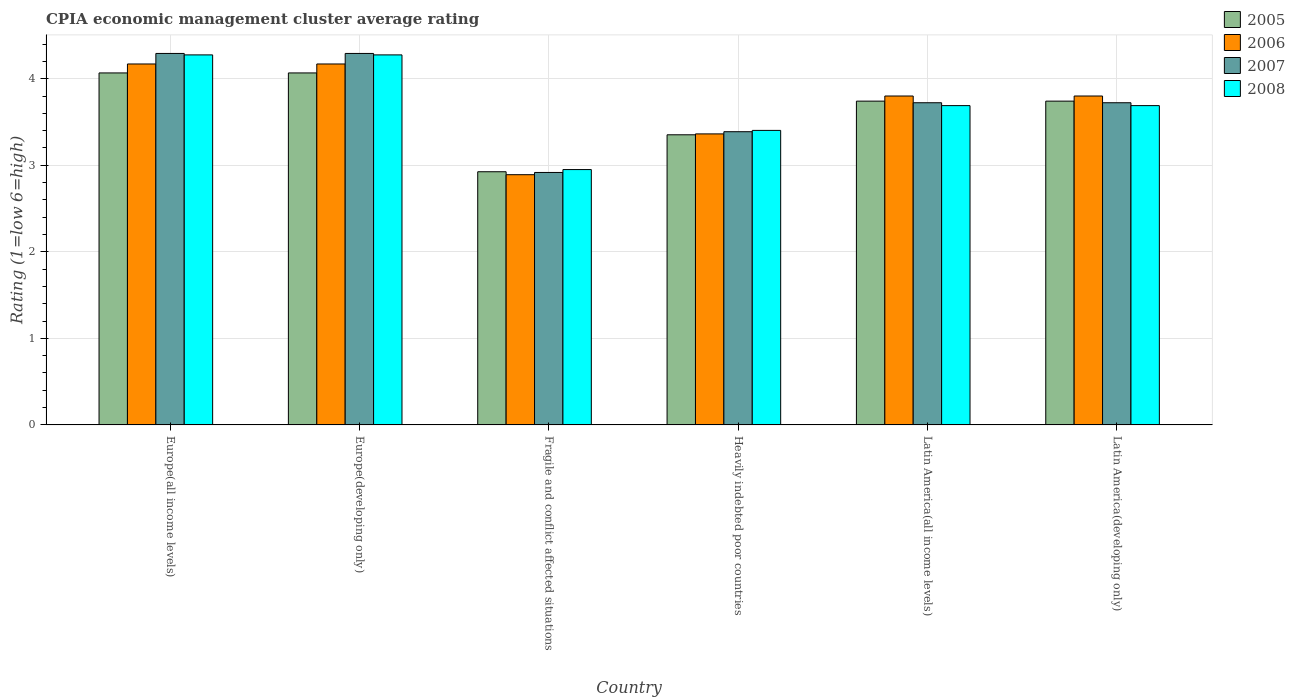Are the number of bars per tick equal to the number of legend labels?
Your answer should be very brief. Yes. Are the number of bars on each tick of the X-axis equal?
Your answer should be compact. Yes. How many bars are there on the 2nd tick from the right?
Make the answer very short. 4. What is the label of the 5th group of bars from the left?
Your answer should be compact. Latin America(all income levels). In how many cases, is the number of bars for a given country not equal to the number of legend labels?
Ensure brevity in your answer.  0. What is the CPIA rating in 2006 in Fragile and conflict affected situations?
Your answer should be very brief. 2.89. Across all countries, what is the maximum CPIA rating in 2006?
Provide a succinct answer. 4.17. Across all countries, what is the minimum CPIA rating in 2006?
Provide a succinct answer. 2.89. In which country was the CPIA rating in 2007 maximum?
Ensure brevity in your answer.  Europe(all income levels). In which country was the CPIA rating in 2006 minimum?
Provide a short and direct response. Fragile and conflict affected situations. What is the total CPIA rating in 2005 in the graph?
Ensure brevity in your answer.  21.89. What is the difference between the CPIA rating in 2006 in Europe(developing only) and that in Fragile and conflict affected situations?
Provide a succinct answer. 1.28. What is the difference between the CPIA rating in 2008 in Fragile and conflict affected situations and the CPIA rating in 2005 in Heavily indebted poor countries?
Make the answer very short. -0.4. What is the average CPIA rating in 2005 per country?
Provide a short and direct response. 3.65. What is the difference between the CPIA rating of/in 2006 and CPIA rating of/in 2008 in Fragile and conflict affected situations?
Make the answer very short. -0.06. What is the ratio of the CPIA rating in 2006 in Europe(developing only) to that in Latin America(all income levels)?
Your answer should be compact. 1.1. Is the difference between the CPIA rating in 2006 in Europe(developing only) and Latin America(all income levels) greater than the difference between the CPIA rating in 2008 in Europe(developing only) and Latin America(all income levels)?
Offer a terse response. No. What is the difference between the highest and the second highest CPIA rating in 2007?
Your response must be concise. -0.57. What is the difference between the highest and the lowest CPIA rating in 2006?
Your response must be concise. 1.28. Is it the case that in every country, the sum of the CPIA rating in 2007 and CPIA rating in 2005 is greater than the sum of CPIA rating in 2008 and CPIA rating in 2006?
Offer a terse response. No. Is it the case that in every country, the sum of the CPIA rating in 2005 and CPIA rating in 2006 is greater than the CPIA rating in 2008?
Your answer should be compact. Yes. How many bars are there?
Ensure brevity in your answer.  24. Are the values on the major ticks of Y-axis written in scientific E-notation?
Keep it short and to the point. No. Where does the legend appear in the graph?
Provide a succinct answer. Top right. How are the legend labels stacked?
Give a very brief answer. Vertical. What is the title of the graph?
Your answer should be compact. CPIA economic management cluster average rating. Does "1971" appear as one of the legend labels in the graph?
Keep it short and to the point. No. What is the label or title of the Y-axis?
Your answer should be compact. Rating (1=low 6=high). What is the Rating (1=low 6=high) in 2005 in Europe(all income levels)?
Give a very brief answer. 4.07. What is the Rating (1=low 6=high) of 2006 in Europe(all income levels)?
Make the answer very short. 4.17. What is the Rating (1=low 6=high) of 2007 in Europe(all income levels)?
Keep it short and to the point. 4.29. What is the Rating (1=low 6=high) of 2008 in Europe(all income levels)?
Your response must be concise. 4.28. What is the Rating (1=low 6=high) of 2005 in Europe(developing only)?
Provide a succinct answer. 4.07. What is the Rating (1=low 6=high) of 2006 in Europe(developing only)?
Provide a succinct answer. 4.17. What is the Rating (1=low 6=high) of 2007 in Europe(developing only)?
Provide a succinct answer. 4.29. What is the Rating (1=low 6=high) of 2008 in Europe(developing only)?
Provide a succinct answer. 4.28. What is the Rating (1=low 6=high) of 2005 in Fragile and conflict affected situations?
Your answer should be very brief. 2.92. What is the Rating (1=low 6=high) of 2006 in Fragile and conflict affected situations?
Ensure brevity in your answer.  2.89. What is the Rating (1=low 6=high) of 2007 in Fragile and conflict affected situations?
Keep it short and to the point. 2.92. What is the Rating (1=low 6=high) in 2008 in Fragile and conflict affected situations?
Offer a very short reply. 2.95. What is the Rating (1=low 6=high) in 2005 in Heavily indebted poor countries?
Offer a very short reply. 3.35. What is the Rating (1=low 6=high) of 2006 in Heavily indebted poor countries?
Your response must be concise. 3.36. What is the Rating (1=low 6=high) in 2007 in Heavily indebted poor countries?
Offer a very short reply. 3.39. What is the Rating (1=low 6=high) of 2008 in Heavily indebted poor countries?
Give a very brief answer. 3.4. What is the Rating (1=low 6=high) in 2005 in Latin America(all income levels)?
Provide a succinct answer. 3.74. What is the Rating (1=low 6=high) in 2007 in Latin America(all income levels)?
Offer a very short reply. 3.72. What is the Rating (1=low 6=high) of 2008 in Latin America(all income levels)?
Your answer should be very brief. 3.69. What is the Rating (1=low 6=high) of 2005 in Latin America(developing only)?
Ensure brevity in your answer.  3.74. What is the Rating (1=low 6=high) in 2006 in Latin America(developing only)?
Give a very brief answer. 3.8. What is the Rating (1=low 6=high) of 2007 in Latin America(developing only)?
Provide a short and direct response. 3.72. What is the Rating (1=low 6=high) in 2008 in Latin America(developing only)?
Your answer should be compact. 3.69. Across all countries, what is the maximum Rating (1=low 6=high) of 2005?
Your response must be concise. 4.07. Across all countries, what is the maximum Rating (1=low 6=high) in 2006?
Offer a terse response. 4.17. Across all countries, what is the maximum Rating (1=low 6=high) in 2007?
Make the answer very short. 4.29. Across all countries, what is the maximum Rating (1=low 6=high) in 2008?
Offer a very short reply. 4.28. Across all countries, what is the minimum Rating (1=low 6=high) of 2005?
Offer a very short reply. 2.92. Across all countries, what is the minimum Rating (1=low 6=high) in 2006?
Offer a terse response. 2.89. Across all countries, what is the minimum Rating (1=low 6=high) in 2007?
Your answer should be very brief. 2.92. Across all countries, what is the minimum Rating (1=low 6=high) in 2008?
Provide a succinct answer. 2.95. What is the total Rating (1=low 6=high) of 2005 in the graph?
Your answer should be compact. 21.89. What is the total Rating (1=low 6=high) of 2006 in the graph?
Your answer should be very brief. 22.19. What is the total Rating (1=low 6=high) of 2007 in the graph?
Your answer should be very brief. 22.33. What is the total Rating (1=low 6=high) in 2008 in the graph?
Give a very brief answer. 22.28. What is the difference between the Rating (1=low 6=high) of 2006 in Europe(all income levels) and that in Europe(developing only)?
Keep it short and to the point. 0. What is the difference between the Rating (1=low 6=high) in 2005 in Europe(all income levels) and that in Fragile and conflict affected situations?
Ensure brevity in your answer.  1.14. What is the difference between the Rating (1=low 6=high) of 2006 in Europe(all income levels) and that in Fragile and conflict affected situations?
Your response must be concise. 1.28. What is the difference between the Rating (1=low 6=high) in 2007 in Europe(all income levels) and that in Fragile and conflict affected situations?
Provide a short and direct response. 1.38. What is the difference between the Rating (1=low 6=high) of 2008 in Europe(all income levels) and that in Fragile and conflict affected situations?
Keep it short and to the point. 1.32. What is the difference between the Rating (1=low 6=high) of 2005 in Europe(all income levels) and that in Heavily indebted poor countries?
Your answer should be compact. 0.71. What is the difference between the Rating (1=low 6=high) of 2006 in Europe(all income levels) and that in Heavily indebted poor countries?
Make the answer very short. 0.81. What is the difference between the Rating (1=low 6=high) of 2007 in Europe(all income levels) and that in Heavily indebted poor countries?
Offer a terse response. 0.9. What is the difference between the Rating (1=low 6=high) in 2008 in Europe(all income levels) and that in Heavily indebted poor countries?
Ensure brevity in your answer.  0.87. What is the difference between the Rating (1=low 6=high) of 2005 in Europe(all income levels) and that in Latin America(all income levels)?
Give a very brief answer. 0.33. What is the difference between the Rating (1=low 6=high) in 2006 in Europe(all income levels) and that in Latin America(all income levels)?
Your response must be concise. 0.37. What is the difference between the Rating (1=low 6=high) in 2007 in Europe(all income levels) and that in Latin America(all income levels)?
Provide a succinct answer. 0.57. What is the difference between the Rating (1=low 6=high) in 2008 in Europe(all income levels) and that in Latin America(all income levels)?
Your answer should be very brief. 0.59. What is the difference between the Rating (1=low 6=high) of 2005 in Europe(all income levels) and that in Latin America(developing only)?
Keep it short and to the point. 0.33. What is the difference between the Rating (1=low 6=high) of 2006 in Europe(all income levels) and that in Latin America(developing only)?
Give a very brief answer. 0.37. What is the difference between the Rating (1=low 6=high) in 2007 in Europe(all income levels) and that in Latin America(developing only)?
Provide a short and direct response. 0.57. What is the difference between the Rating (1=low 6=high) of 2008 in Europe(all income levels) and that in Latin America(developing only)?
Ensure brevity in your answer.  0.59. What is the difference between the Rating (1=low 6=high) of 2005 in Europe(developing only) and that in Fragile and conflict affected situations?
Provide a succinct answer. 1.14. What is the difference between the Rating (1=low 6=high) of 2006 in Europe(developing only) and that in Fragile and conflict affected situations?
Ensure brevity in your answer.  1.28. What is the difference between the Rating (1=low 6=high) in 2007 in Europe(developing only) and that in Fragile and conflict affected situations?
Give a very brief answer. 1.38. What is the difference between the Rating (1=low 6=high) of 2008 in Europe(developing only) and that in Fragile and conflict affected situations?
Keep it short and to the point. 1.32. What is the difference between the Rating (1=low 6=high) in 2005 in Europe(developing only) and that in Heavily indebted poor countries?
Make the answer very short. 0.71. What is the difference between the Rating (1=low 6=high) of 2006 in Europe(developing only) and that in Heavily indebted poor countries?
Provide a succinct answer. 0.81. What is the difference between the Rating (1=low 6=high) of 2007 in Europe(developing only) and that in Heavily indebted poor countries?
Make the answer very short. 0.9. What is the difference between the Rating (1=low 6=high) in 2008 in Europe(developing only) and that in Heavily indebted poor countries?
Provide a short and direct response. 0.87. What is the difference between the Rating (1=low 6=high) in 2005 in Europe(developing only) and that in Latin America(all income levels)?
Provide a succinct answer. 0.33. What is the difference between the Rating (1=low 6=high) of 2006 in Europe(developing only) and that in Latin America(all income levels)?
Offer a terse response. 0.37. What is the difference between the Rating (1=low 6=high) of 2007 in Europe(developing only) and that in Latin America(all income levels)?
Offer a terse response. 0.57. What is the difference between the Rating (1=low 6=high) of 2008 in Europe(developing only) and that in Latin America(all income levels)?
Provide a short and direct response. 0.59. What is the difference between the Rating (1=low 6=high) of 2005 in Europe(developing only) and that in Latin America(developing only)?
Offer a terse response. 0.33. What is the difference between the Rating (1=low 6=high) in 2006 in Europe(developing only) and that in Latin America(developing only)?
Your answer should be very brief. 0.37. What is the difference between the Rating (1=low 6=high) of 2007 in Europe(developing only) and that in Latin America(developing only)?
Offer a terse response. 0.57. What is the difference between the Rating (1=low 6=high) in 2008 in Europe(developing only) and that in Latin America(developing only)?
Make the answer very short. 0.59. What is the difference between the Rating (1=low 6=high) in 2005 in Fragile and conflict affected situations and that in Heavily indebted poor countries?
Offer a very short reply. -0.43. What is the difference between the Rating (1=low 6=high) of 2006 in Fragile and conflict affected situations and that in Heavily indebted poor countries?
Make the answer very short. -0.47. What is the difference between the Rating (1=low 6=high) of 2007 in Fragile and conflict affected situations and that in Heavily indebted poor countries?
Ensure brevity in your answer.  -0.47. What is the difference between the Rating (1=low 6=high) in 2008 in Fragile and conflict affected situations and that in Heavily indebted poor countries?
Keep it short and to the point. -0.45. What is the difference between the Rating (1=low 6=high) in 2005 in Fragile and conflict affected situations and that in Latin America(all income levels)?
Your answer should be compact. -0.82. What is the difference between the Rating (1=low 6=high) in 2006 in Fragile and conflict affected situations and that in Latin America(all income levels)?
Your response must be concise. -0.91. What is the difference between the Rating (1=low 6=high) in 2007 in Fragile and conflict affected situations and that in Latin America(all income levels)?
Ensure brevity in your answer.  -0.81. What is the difference between the Rating (1=low 6=high) in 2008 in Fragile and conflict affected situations and that in Latin America(all income levels)?
Make the answer very short. -0.74. What is the difference between the Rating (1=low 6=high) of 2005 in Fragile and conflict affected situations and that in Latin America(developing only)?
Offer a very short reply. -0.82. What is the difference between the Rating (1=low 6=high) of 2006 in Fragile and conflict affected situations and that in Latin America(developing only)?
Offer a very short reply. -0.91. What is the difference between the Rating (1=low 6=high) in 2007 in Fragile and conflict affected situations and that in Latin America(developing only)?
Offer a terse response. -0.81. What is the difference between the Rating (1=low 6=high) of 2008 in Fragile and conflict affected situations and that in Latin America(developing only)?
Ensure brevity in your answer.  -0.74. What is the difference between the Rating (1=low 6=high) of 2005 in Heavily indebted poor countries and that in Latin America(all income levels)?
Offer a terse response. -0.39. What is the difference between the Rating (1=low 6=high) of 2006 in Heavily indebted poor countries and that in Latin America(all income levels)?
Offer a very short reply. -0.44. What is the difference between the Rating (1=low 6=high) in 2007 in Heavily indebted poor countries and that in Latin America(all income levels)?
Your answer should be very brief. -0.33. What is the difference between the Rating (1=low 6=high) in 2008 in Heavily indebted poor countries and that in Latin America(all income levels)?
Give a very brief answer. -0.29. What is the difference between the Rating (1=low 6=high) in 2005 in Heavily indebted poor countries and that in Latin America(developing only)?
Offer a very short reply. -0.39. What is the difference between the Rating (1=low 6=high) of 2006 in Heavily indebted poor countries and that in Latin America(developing only)?
Make the answer very short. -0.44. What is the difference between the Rating (1=low 6=high) of 2007 in Heavily indebted poor countries and that in Latin America(developing only)?
Offer a very short reply. -0.33. What is the difference between the Rating (1=low 6=high) in 2008 in Heavily indebted poor countries and that in Latin America(developing only)?
Provide a succinct answer. -0.29. What is the difference between the Rating (1=low 6=high) of 2005 in Latin America(all income levels) and that in Latin America(developing only)?
Ensure brevity in your answer.  0. What is the difference between the Rating (1=low 6=high) of 2007 in Latin America(all income levels) and that in Latin America(developing only)?
Provide a succinct answer. 0. What is the difference between the Rating (1=low 6=high) in 2005 in Europe(all income levels) and the Rating (1=low 6=high) in 2006 in Europe(developing only)?
Give a very brief answer. -0.1. What is the difference between the Rating (1=low 6=high) in 2005 in Europe(all income levels) and the Rating (1=low 6=high) in 2007 in Europe(developing only)?
Ensure brevity in your answer.  -0.23. What is the difference between the Rating (1=low 6=high) of 2005 in Europe(all income levels) and the Rating (1=low 6=high) of 2008 in Europe(developing only)?
Offer a terse response. -0.21. What is the difference between the Rating (1=low 6=high) of 2006 in Europe(all income levels) and the Rating (1=low 6=high) of 2007 in Europe(developing only)?
Keep it short and to the point. -0.12. What is the difference between the Rating (1=low 6=high) in 2006 in Europe(all income levels) and the Rating (1=low 6=high) in 2008 in Europe(developing only)?
Offer a very short reply. -0.1. What is the difference between the Rating (1=low 6=high) of 2007 in Europe(all income levels) and the Rating (1=low 6=high) of 2008 in Europe(developing only)?
Your response must be concise. 0.02. What is the difference between the Rating (1=low 6=high) in 2005 in Europe(all income levels) and the Rating (1=low 6=high) in 2006 in Fragile and conflict affected situations?
Your answer should be compact. 1.18. What is the difference between the Rating (1=low 6=high) in 2005 in Europe(all income levels) and the Rating (1=low 6=high) in 2007 in Fragile and conflict affected situations?
Keep it short and to the point. 1.15. What is the difference between the Rating (1=low 6=high) in 2005 in Europe(all income levels) and the Rating (1=low 6=high) in 2008 in Fragile and conflict affected situations?
Ensure brevity in your answer.  1.12. What is the difference between the Rating (1=low 6=high) of 2006 in Europe(all income levels) and the Rating (1=low 6=high) of 2007 in Fragile and conflict affected situations?
Give a very brief answer. 1.25. What is the difference between the Rating (1=low 6=high) of 2006 in Europe(all income levels) and the Rating (1=low 6=high) of 2008 in Fragile and conflict affected situations?
Offer a terse response. 1.22. What is the difference between the Rating (1=low 6=high) in 2007 in Europe(all income levels) and the Rating (1=low 6=high) in 2008 in Fragile and conflict affected situations?
Your answer should be very brief. 1.34. What is the difference between the Rating (1=low 6=high) of 2005 in Europe(all income levels) and the Rating (1=low 6=high) of 2006 in Heavily indebted poor countries?
Your answer should be compact. 0.7. What is the difference between the Rating (1=low 6=high) of 2005 in Europe(all income levels) and the Rating (1=low 6=high) of 2007 in Heavily indebted poor countries?
Your answer should be very brief. 0.68. What is the difference between the Rating (1=low 6=high) of 2005 in Europe(all income levels) and the Rating (1=low 6=high) of 2008 in Heavily indebted poor countries?
Make the answer very short. 0.66. What is the difference between the Rating (1=low 6=high) of 2006 in Europe(all income levels) and the Rating (1=low 6=high) of 2007 in Heavily indebted poor countries?
Provide a short and direct response. 0.78. What is the difference between the Rating (1=low 6=high) of 2006 in Europe(all income levels) and the Rating (1=low 6=high) of 2008 in Heavily indebted poor countries?
Make the answer very short. 0.77. What is the difference between the Rating (1=low 6=high) in 2007 in Europe(all income levels) and the Rating (1=low 6=high) in 2008 in Heavily indebted poor countries?
Offer a very short reply. 0.89. What is the difference between the Rating (1=low 6=high) of 2005 in Europe(all income levels) and the Rating (1=low 6=high) of 2006 in Latin America(all income levels)?
Provide a short and direct response. 0.27. What is the difference between the Rating (1=low 6=high) of 2005 in Europe(all income levels) and the Rating (1=low 6=high) of 2007 in Latin America(all income levels)?
Make the answer very short. 0.34. What is the difference between the Rating (1=low 6=high) in 2005 in Europe(all income levels) and the Rating (1=low 6=high) in 2008 in Latin America(all income levels)?
Keep it short and to the point. 0.38. What is the difference between the Rating (1=low 6=high) of 2006 in Europe(all income levels) and the Rating (1=low 6=high) of 2007 in Latin America(all income levels)?
Your answer should be very brief. 0.45. What is the difference between the Rating (1=low 6=high) in 2006 in Europe(all income levels) and the Rating (1=low 6=high) in 2008 in Latin America(all income levels)?
Ensure brevity in your answer.  0.48. What is the difference between the Rating (1=low 6=high) in 2007 in Europe(all income levels) and the Rating (1=low 6=high) in 2008 in Latin America(all income levels)?
Ensure brevity in your answer.  0.6. What is the difference between the Rating (1=low 6=high) of 2005 in Europe(all income levels) and the Rating (1=low 6=high) of 2006 in Latin America(developing only)?
Your answer should be compact. 0.27. What is the difference between the Rating (1=low 6=high) of 2005 in Europe(all income levels) and the Rating (1=low 6=high) of 2007 in Latin America(developing only)?
Offer a terse response. 0.34. What is the difference between the Rating (1=low 6=high) of 2005 in Europe(all income levels) and the Rating (1=low 6=high) of 2008 in Latin America(developing only)?
Offer a very short reply. 0.38. What is the difference between the Rating (1=low 6=high) of 2006 in Europe(all income levels) and the Rating (1=low 6=high) of 2007 in Latin America(developing only)?
Offer a terse response. 0.45. What is the difference between the Rating (1=low 6=high) of 2006 in Europe(all income levels) and the Rating (1=low 6=high) of 2008 in Latin America(developing only)?
Offer a terse response. 0.48. What is the difference between the Rating (1=low 6=high) of 2007 in Europe(all income levels) and the Rating (1=low 6=high) of 2008 in Latin America(developing only)?
Your response must be concise. 0.6. What is the difference between the Rating (1=low 6=high) in 2005 in Europe(developing only) and the Rating (1=low 6=high) in 2006 in Fragile and conflict affected situations?
Keep it short and to the point. 1.18. What is the difference between the Rating (1=low 6=high) of 2005 in Europe(developing only) and the Rating (1=low 6=high) of 2007 in Fragile and conflict affected situations?
Provide a succinct answer. 1.15. What is the difference between the Rating (1=low 6=high) in 2005 in Europe(developing only) and the Rating (1=low 6=high) in 2008 in Fragile and conflict affected situations?
Your answer should be very brief. 1.12. What is the difference between the Rating (1=low 6=high) in 2006 in Europe(developing only) and the Rating (1=low 6=high) in 2007 in Fragile and conflict affected situations?
Your answer should be compact. 1.25. What is the difference between the Rating (1=low 6=high) of 2006 in Europe(developing only) and the Rating (1=low 6=high) of 2008 in Fragile and conflict affected situations?
Your answer should be very brief. 1.22. What is the difference between the Rating (1=low 6=high) in 2007 in Europe(developing only) and the Rating (1=low 6=high) in 2008 in Fragile and conflict affected situations?
Offer a terse response. 1.34. What is the difference between the Rating (1=low 6=high) of 2005 in Europe(developing only) and the Rating (1=low 6=high) of 2006 in Heavily indebted poor countries?
Your answer should be compact. 0.7. What is the difference between the Rating (1=low 6=high) in 2005 in Europe(developing only) and the Rating (1=low 6=high) in 2007 in Heavily indebted poor countries?
Your answer should be compact. 0.68. What is the difference between the Rating (1=low 6=high) in 2005 in Europe(developing only) and the Rating (1=low 6=high) in 2008 in Heavily indebted poor countries?
Your response must be concise. 0.66. What is the difference between the Rating (1=low 6=high) in 2006 in Europe(developing only) and the Rating (1=low 6=high) in 2007 in Heavily indebted poor countries?
Offer a terse response. 0.78. What is the difference between the Rating (1=low 6=high) in 2006 in Europe(developing only) and the Rating (1=low 6=high) in 2008 in Heavily indebted poor countries?
Give a very brief answer. 0.77. What is the difference between the Rating (1=low 6=high) in 2007 in Europe(developing only) and the Rating (1=low 6=high) in 2008 in Heavily indebted poor countries?
Your answer should be compact. 0.89. What is the difference between the Rating (1=low 6=high) in 2005 in Europe(developing only) and the Rating (1=low 6=high) in 2006 in Latin America(all income levels)?
Your response must be concise. 0.27. What is the difference between the Rating (1=low 6=high) in 2005 in Europe(developing only) and the Rating (1=low 6=high) in 2007 in Latin America(all income levels)?
Offer a very short reply. 0.34. What is the difference between the Rating (1=low 6=high) of 2005 in Europe(developing only) and the Rating (1=low 6=high) of 2008 in Latin America(all income levels)?
Provide a short and direct response. 0.38. What is the difference between the Rating (1=low 6=high) in 2006 in Europe(developing only) and the Rating (1=low 6=high) in 2007 in Latin America(all income levels)?
Your answer should be very brief. 0.45. What is the difference between the Rating (1=low 6=high) of 2006 in Europe(developing only) and the Rating (1=low 6=high) of 2008 in Latin America(all income levels)?
Offer a very short reply. 0.48. What is the difference between the Rating (1=low 6=high) of 2007 in Europe(developing only) and the Rating (1=low 6=high) of 2008 in Latin America(all income levels)?
Your answer should be compact. 0.6. What is the difference between the Rating (1=low 6=high) in 2005 in Europe(developing only) and the Rating (1=low 6=high) in 2006 in Latin America(developing only)?
Your answer should be compact. 0.27. What is the difference between the Rating (1=low 6=high) of 2005 in Europe(developing only) and the Rating (1=low 6=high) of 2007 in Latin America(developing only)?
Keep it short and to the point. 0.34. What is the difference between the Rating (1=low 6=high) of 2005 in Europe(developing only) and the Rating (1=low 6=high) of 2008 in Latin America(developing only)?
Give a very brief answer. 0.38. What is the difference between the Rating (1=low 6=high) in 2006 in Europe(developing only) and the Rating (1=low 6=high) in 2007 in Latin America(developing only)?
Keep it short and to the point. 0.45. What is the difference between the Rating (1=low 6=high) of 2006 in Europe(developing only) and the Rating (1=low 6=high) of 2008 in Latin America(developing only)?
Offer a very short reply. 0.48. What is the difference between the Rating (1=low 6=high) in 2007 in Europe(developing only) and the Rating (1=low 6=high) in 2008 in Latin America(developing only)?
Give a very brief answer. 0.6. What is the difference between the Rating (1=low 6=high) in 2005 in Fragile and conflict affected situations and the Rating (1=low 6=high) in 2006 in Heavily indebted poor countries?
Ensure brevity in your answer.  -0.44. What is the difference between the Rating (1=low 6=high) in 2005 in Fragile and conflict affected situations and the Rating (1=low 6=high) in 2007 in Heavily indebted poor countries?
Your response must be concise. -0.46. What is the difference between the Rating (1=low 6=high) of 2005 in Fragile and conflict affected situations and the Rating (1=low 6=high) of 2008 in Heavily indebted poor countries?
Make the answer very short. -0.48. What is the difference between the Rating (1=low 6=high) in 2006 in Fragile and conflict affected situations and the Rating (1=low 6=high) in 2007 in Heavily indebted poor countries?
Your answer should be compact. -0.5. What is the difference between the Rating (1=low 6=high) in 2006 in Fragile and conflict affected situations and the Rating (1=low 6=high) in 2008 in Heavily indebted poor countries?
Ensure brevity in your answer.  -0.51. What is the difference between the Rating (1=low 6=high) of 2007 in Fragile and conflict affected situations and the Rating (1=low 6=high) of 2008 in Heavily indebted poor countries?
Your response must be concise. -0.49. What is the difference between the Rating (1=low 6=high) in 2005 in Fragile and conflict affected situations and the Rating (1=low 6=high) in 2006 in Latin America(all income levels)?
Give a very brief answer. -0.88. What is the difference between the Rating (1=low 6=high) of 2005 in Fragile and conflict affected situations and the Rating (1=low 6=high) of 2007 in Latin America(all income levels)?
Keep it short and to the point. -0.8. What is the difference between the Rating (1=low 6=high) of 2005 in Fragile and conflict affected situations and the Rating (1=low 6=high) of 2008 in Latin America(all income levels)?
Provide a succinct answer. -0.76. What is the difference between the Rating (1=low 6=high) in 2006 in Fragile and conflict affected situations and the Rating (1=low 6=high) in 2007 in Latin America(all income levels)?
Your answer should be compact. -0.83. What is the difference between the Rating (1=low 6=high) of 2006 in Fragile and conflict affected situations and the Rating (1=low 6=high) of 2008 in Latin America(all income levels)?
Your answer should be compact. -0.8. What is the difference between the Rating (1=low 6=high) of 2007 in Fragile and conflict affected situations and the Rating (1=low 6=high) of 2008 in Latin America(all income levels)?
Give a very brief answer. -0.77. What is the difference between the Rating (1=low 6=high) of 2005 in Fragile and conflict affected situations and the Rating (1=low 6=high) of 2006 in Latin America(developing only)?
Provide a short and direct response. -0.88. What is the difference between the Rating (1=low 6=high) in 2005 in Fragile and conflict affected situations and the Rating (1=low 6=high) in 2007 in Latin America(developing only)?
Offer a terse response. -0.8. What is the difference between the Rating (1=low 6=high) in 2005 in Fragile and conflict affected situations and the Rating (1=low 6=high) in 2008 in Latin America(developing only)?
Keep it short and to the point. -0.76. What is the difference between the Rating (1=low 6=high) in 2006 in Fragile and conflict affected situations and the Rating (1=low 6=high) in 2007 in Latin America(developing only)?
Make the answer very short. -0.83. What is the difference between the Rating (1=low 6=high) in 2006 in Fragile and conflict affected situations and the Rating (1=low 6=high) in 2008 in Latin America(developing only)?
Your answer should be very brief. -0.8. What is the difference between the Rating (1=low 6=high) of 2007 in Fragile and conflict affected situations and the Rating (1=low 6=high) of 2008 in Latin America(developing only)?
Provide a succinct answer. -0.77. What is the difference between the Rating (1=low 6=high) of 2005 in Heavily indebted poor countries and the Rating (1=low 6=high) of 2006 in Latin America(all income levels)?
Your response must be concise. -0.45. What is the difference between the Rating (1=low 6=high) of 2005 in Heavily indebted poor countries and the Rating (1=low 6=high) of 2007 in Latin America(all income levels)?
Offer a terse response. -0.37. What is the difference between the Rating (1=low 6=high) in 2005 in Heavily indebted poor countries and the Rating (1=low 6=high) in 2008 in Latin America(all income levels)?
Offer a terse response. -0.34. What is the difference between the Rating (1=low 6=high) of 2006 in Heavily indebted poor countries and the Rating (1=low 6=high) of 2007 in Latin America(all income levels)?
Give a very brief answer. -0.36. What is the difference between the Rating (1=low 6=high) of 2006 in Heavily indebted poor countries and the Rating (1=low 6=high) of 2008 in Latin America(all income levels)?
Your answer should be compact. -0.33. What is the difference between the Rating (1=low 6=high) in 2007 in Heavily indebted poor countries and the Rating (1=low 6=high) in 2008 in Latin America(all income levels)?
Keep it short and to the point. -0.3. What is the difference between the Rating (1=low 6=high) of 2005 in Heavily indebted poor countries and the Rating (1=low 6=high) of 2006 in Latin America(developing only)?
Provide a short and direct response. -0.45. What is the difference between the Rating (1=low 6=high) of 2005 in Heavily indebted poor countries and the Rating (1=low 6=high) of 2007 in Latin America(developing only)?
Your answer should be compact. -0.37. What is the difference between the Rating (1=low 6=high) of 2005 in Heavily indebted poor countries and the Rating (1=low 6=high) of 2008 in Latin America(developing only)?
Make the answer very short. -0.34. What is the difference between the Rating (1=low 6=high) of 2006 in Heavily indebted poor countries and the Rating (1=low 6=high) of 2007 in Latin America(developing only)?
Your response must be concise. -0.36. What is the difference between the Rating (1=low 6=high) in 2006 in Heavily indebted poor countries and the Rating (1=low 6=high) in 2008 in Latin America(developing only)?
Provide a succinct answer. -0.33. What is the difference between the Rating (1=low 6=high) of 2007 in Heavily indebted poor countries and the Rating (1=low 6=high) of 2008 in Latin America(developing only)?
Offer a very short reply. -0.3. What is the difference between the Rating (1=low 6=high) of 2005 in Latin America(all income levels) and the Rating (1=low 6=high) of 2006 in Latin America(developing only)?
Keep it short and to the point. -0.06. What is the difference between the Rating (1=low 6=high) of 2005 in Latin America(all income levels) and the Rating (1=low 6=high) of 2007 in Latin America(developing only)?
Make the answer very short. 0.02. What is the difference between the Rating (1=low 6=high) in 2005 in Latin America(all income levels) and the Rating (1=low 6=high) in 2008 in Latin America(developing only)?
Make the answer very short. 0.05. What is the difference between the Rating (1=low 6=high) of 2006 in Latin America(all income levels) and the Rating (1=low 6=high) of 2007 in Latin America(developing only)?
Offer a terse response. 0.08. What is the difference between the Rating (1=low 6=high) of 2007 in Latin America(all income levels) and the Rating (1=low 6=high) of 2008 in Latin America(developing only)?
Provide a succinct answer. 0.03. What is the average Rating (1=low 6=high) of 2005 per country?
Provide a succinct answer. 3.65. What is the average Rating (1=low 6=high) in 2006 per country?
Your answer should be compact. 3.7. What is the average Rating (1=low 6=high) in 2007 per country?
Your response must be concise. 3.72. What is the average Rating (1=low 6=high) of 2008 per country?
Your response must be concise. 3.71. What is the difference between the Rating (1=low 6=high) in 2005 and Rating (1=low 6=high) in 2006 in Europe(all income levels)?
Your answer should be compact. -0.1. What is the difference between the Rating (1=low 6=high) of 2005 and Rating (1=low 6=high) of 2007 in Europe(all income levels)?
Offer a very short reply. -0.23. What is the difference between the Rating (1=low 6=high) in 2005 and Rating (1=low 6=high) in 2008 in Europe(all income levels)?
Ensure brevity in your answer.  -0.21. What is the difference between the Rating (1=low 6=high) of 2006 and Rating (1=low 6=high) of 2007 in Europe(all income levels)?
Ensure brevity in your answer.  -0.12. What is the difference between the Rating (1=low 6=high) of 2006 and Rating (1=low 6=high) of 2008 in Europe(all income levels)?
Offer a very short reply. -0.1. What is the difference between the Rating (1=low 6=high) of 2007 and Rating (1=low 6=high) of 2008 in Europe(all income levels)?
Provide a succinct answer. 0.02. What is the difference between the Rating (1=low 6=high) of 2005 and Rating (1=low 6=high) of 2006 in Europe(developing only)?
Your response must be concise. -0.1. What is the difference between the Rating (1=low 6=high) of 2005 and Rating (1=low 6=high) of 2007 in Europe(developing only)?
Ensure brevity in your answer.  -0.23. What is the difference between the Rating (1=low 6=high) in 2005 and Rating (1=low 6=high) in 2008 in Europe(developing only)?
Give a very brief answer. -0.21. What is the difference between the Rating (1=low 6=high) of 2006 and Rating (1=low 6=high) of 2007 in Europe(developing only)?
Provide a short and direct response. -0.12. What is the difference between the Rating (1=low 6=high) of 2006 and Rating (1=low 6=high) of 2008 in Europe(developing only)?
Give a very brief answer. -0.1. What is the difference between the Rating (1=low 6=high) in 2007 and Rating (1=low 6=high) in 2008 in Europe(developing only)?
Provide a short and direct response. 0.02. What is the difference between the Rating (1=low 6=high) of 2005 and Rating (1=low 6=high) of 2006 in Fragile and conflict affected situations?
Ensure brevity in your answer.  0.03. What is the difference between the Rating (1=low 6=high) in 2005 and Rating (1=low 6=high) in 2007 in Fragile and conflict affected situations?
Offer a terse response. 0.01. What is the difference between the Rating (1=low 6=high) in 2005 and Rating (1=low 6=high) in 2008 in Fragile and conflict affected situations?
Your answer should be very brief. -0.03. What is the difference between the Rating (1=low 6=high) of 2006 and Rating (1=low 6=high) of 2007 in Fragile and conflict affected situations?
Keep it short and to the point. -0.03. What is the difference between the Rating (1=low 6=high) in 2006 and Rating (1=low 6=high) in 2008 in Fragile and conflict affected situations?
Ensure brevity in your answer.  -0.06. What is the difference between the Rating (1=low 6=high) in 2007 and Rating (1=low 6=high) in 2008 in Fragile and conflict affected situations?
Provide a short and direct response. -0.03. What is the difference between the Rating (1=low 6=high) in 2005 and Rating (1=low 6=high) in 2006 in Heavily indebted poor countries?
Ensure brevity in your answer.  -0.01. What is the difference between the Rating (1=low 6=high) in 2005 and Rating (1=low 6=high) in 2007 in Heavily indebted poor countries?
Your answer should be compact. -0.04. What is the difference between the Rating (1=low 6=high) in 2005 and Rating (1=low 6=high) in 2008 in Heavily indebted poor countries?
Make the answer very short. -0.05. What is the difference between the Rating (1=low 6=high) of 2006 and Rating (1=low 6=high) of 2007 in Heavily indebted poor countries?
Keep it short and to the point. -0.03. What is the difference between the Rating (1=low 6=high) in 2006 and Rating (1=low 6=high) in 2008 in Heavily indebted poor countries?
Offer a terse response. -0.04. What is the difference between the Rating (1=low 6=high) in 2007 and Rating (1=low 6=high) in 2008 in Heavily indebted poor countries?
Ensure brevity in your answer.  -0.02. What is the difference between the Rating (1=low 6=high) of 2005 and Rating (1=low 6=high) of 2006 in Latin America(all income levels)?
Provide a succinct answer. -0.06. What is the difference between the Rating (1=low 6=high) of 2005 and Rating (1=low 6=high) of 2007 in Latin America(all income levels)?
Provide a short and direct response. 0.02. What is the difference between the Rating (1=low 6=high) in 2005 and Rating (1=low 6=high) in 2008 in Latin America(all income levels)?
Make the answer very short. 0.05. What is the difference between the Rating (1=low 6=high) of 2006 and Rating (1=low 6=high) of 2007 in Latin America(all income levels)?
Give a very brief answer. 0.08. What is the difference between the Rating (1=low 6=high) of 2005 and Rating (1=low 6=high) of 2006 in Latin America(developing only)?
Give a very brief answer. -0.06. What is the difference between the Rating (1=low 6=high) in 2005 and Rating (1=low 6=high) in 2007 in Latin America(developing only)?
Your response must be concise. 0.02. What is the difference between the Rating (1=low 6=high) of 2005 and Rating (1=low 6=high) of 2008 in Latin America(developing only)?
Make the answer very short. 0.05. What is the difference between the Rating (1=low 6=high) in 2006 and Rating (1=low 6=high) in 2007 in Latin America(developing only)?
Give a very brief answer. 0.08. What is the ratio of the Rating (1=low 6=high) in 2005 in Europe(all income levels) to that in Fragile and conflict affected situations?
Offer a terse response. 1.39. What is the ratio of the Rating (1=low 6=high) in 2006 in Europe(all income levels) to that in Fragile and conflict affected situations?
Your response must be concise. 1.44. What is the ratio of the Rating (1=low 6=high) of 2007 in Europe(all income levels) to that in Fragile and conflict affected situations?
Your response must be concise. 1.47. What is the ratio of the Rating (1=low 6=high) in 2008 in Europe(all income levels) to that in Fragile and conflict affected situations?
Provide a succinct answer. 1.45. What is the ratio of the Rating (1=low 6=high) of 2005 in Europe(all income levels) to that in Heavily indebted poor countries?
Offer a terse response. 1.21. What is the ratio of the Rating (1=low 6=high) in 2006 in Europe(all income levels) to that in Heavily indebted poor countries?
Your answer should be compact. 1.24. What is the ratio of the Rating (1=low 6=high) of 2007 in Europe(all income levels) to that in Heavily indebted poor countries?
Ensure brevity in your answer.  1.27. What is the ratio of the Rating (1=low 6=high) of 2008 in Europe(all income levels) to that in Heavily indebted poor countries?
Ensure brevity in your answer.  1.26. What is the ratio of the Rating (1=low 6=high) in 2005 in Europe(all income levels) to that in Latin America(all income levels)?
Give a very brief answer. 1.09. What is the ratio of the Rating (1=low 6=high) in 2006 in Europe(all income levels) to that in Latin America(all income levels)?
Offer a very short reply. 1.1. What is the ratio of the Rating (1=low 6=high) in 2007 in Europe(all income levels) to that in Latin America(all income levels)?
Offer a terse response. 1.15. What is the ratio of the Rating (1=low 6=high) of 2008 in Europe(all income levels) to that in Latin America(all income levels)?
Your answer should be very brief. 1.16. What is the ratio of the Rating (1=low 6=high) of 2005 in Europe(all income levels) to that in Latin America(developing only)?
Offer a terse response. 1.09. What is the ratio of the Rating (1=low 6=high) in 2006 in Europe(all income levels) to that in Latin America(developing only)?
Your response must be concise. 1.1. What is the ratio of the Rating (1=low 6=high) of 2007 in Europe(all income levels) to that in Latin America(developing only)?
Give a very brief answer. 1.15. What is the ratio of the Rating (1=low 6=high) of 2008 in Europe(all income levels) to that in Latin America(developing only)?
Your answer should be very brief. 1.16. What is the ratio of the Rating (1=low 6=high) in 2005 in Europe(developing only) to that in Fragile and conflict affected situations?
Give a very brief answer. 1.39. What is the ratio of the Rating (1=low 6=high) in 2006 in Europe(developing only) to that in Fragile and conflict affected situations?
Offer a terse response. 1.44. What is the ratio of the Rating (1=low 6=high) in 2007 in Europe(developing only) to that in Fragile and conflict affected situations?
Provide a succinct answer. 1.47. What is the ratio of the Rating (1=low 6=high) in 2008 in Europe(developing only) to that in Fragile and conflict affected situations?
Offer a very short reply. 1.45. What is the ratio of the Rating (1=low 6=high) of 2005 in Europe(developing only) to that in Heavily indebted poor countries?
Your answer should be very brief. 1.21. What is the ratio of the Rating (1=low 6=high) in 2006 in Europe(developing only) to that in Heavily indebted poor countries?
Your answer should be very brief. 1.24. What is the ratio of the Rating (1=low 6=high) of 2007 in Europe(developing only) to that in Heavily indebted poor countries?
Make the answer very short. 1.27. What is the ratio of the Rating (1=low 6=high) in 2008 in Europe(developing only) to that in Heavily indebted poor countries?
Provide a succinct answer. 1.26. What is the ratio of the Rating (1=low 6=high) of 2005 in Europe(developing only) to that in Latin America(all income levels)?
Provide a succinct answer. 1.09. What is the ratio of the Rating (1=low 6=high) in 2006 in Europe(developing only) to that in Latin America(all income levels)?
Offer a terse response. 1.1. What is the ratio of the Rating (1=low 6=high) in 2007 in Europe(developing only) to that in Latin America(all income levels)?
Keep it short and to the point. 1.15. What is the ratio of the Rating (1=low 6=high) of 2008 in Europe(developing only) to that in Latin America(all income levels)?
Your answer should be compact. 1.16. What is the ratio of the Rating (1=low 6=high) in 2005 in Europe(developing only) to that in Latin America(developing only)?
Make the answer very short. 1.09. What is the ratio of the Rating (1=low 6=high) of 2006 in Europe(developing only) to that in Latin America(developing only)?
Keep it short and to the point. 1.1. What is the ratio of the Rating (1=low 6=high) in 2007 in Europe(developing only) to that in Latin America(developing only)?
Offer a terse response. 1.15. What is the ratio of the Rating (1=low 6=high) of 2008 in Europe(developing only) to that in Latin America(developing only)?
Provide a short and direct response. 1.16. What is the ratio of the Rating (1=low 6=high) of 2005 in Fragile and conflict affected situations to that in Heavily indebted poor countries?
Give a very brief answer. 0.87. What is the ratio of the Rating (1=low 6=high) of 2006 in Fragile and conflict affected situations to that in Heavily indebted poor countries?
Give a very brief answer. 0.86. What is the ratio of the Rating (1=low 6=high) in 2007 in Fragile and conflict affected situations to that in Heavily indebted poor countries?
Offer a very short reply. 0.86. What is the ratio of the Rating (1=low 6=high) of 2008 in Fragile and conflict affected situations to that in Heavily indebted poor countries?
Provide a short and direct response. 0.87. What is the ratio of the Rating (1=low 6=high) in 2005 in Fragile and conflict affected situations to that in Latin America(all income levels)?
Your answer should be compact. 0.78. What is the ratio of the Rating (1=low 6=high) of 2006 in Fragile and conflict affected situations to that in Latin America(all income levels)?
Make the answer very short. 0.76. What is the ratio of the Rating (1=low 6=high) of 2007 in Fragile and conflict affected situations to that in Latin America(all income levels)?
Provide a short and direct response. 0.78. What is the ratio of the Rating (1=low 6=high) of 2008 in Fragile and conflict affected situations to that in Latin America(all income levels)?
Your response must be concise. 0.8. What is the ratio of the Rating (1=low 6=high) of 2005 in Fragile and conflict affected situations to that in Latin America(developing only)?
Your response must be concise. 0.78. What is the ratio of the Rating (1=low 6=high) in 2006 in Fragile and conflict affected situations to that in Latin America(developing only)?
Provide a succinct answer. 0.76. What is the ratio of the Rating (1=low 6=high) in 2007 in Fragile and conflict affected situations to that in Latin America(developing only)?
Ensure brevity in your answer.  0.78. What is the ratio of the Rating (1=low 6=high) of 2008 in Fragile and conflict affected situations to that in Latin America(developing only)?
Keep it short and to the point. 0.8. What is the ratio of the Rating (1=low 6=high) of 2005 in Heavily indebted poor countries to that in Latin America(all income levels)?
Give a very brief answer. 0.9. What is the ratio of the Rating (1=low 6=high) of 2006 in Heavily indebted poor countries to that in Latin America(all income levels)?
Provide a succinct answer. 0.88. What is the ratio of the Rating (1=low 6=high) in 2007 in Heavily indebted poor countries to that in Latin America(all income levels)?
Your answer should be very brief. 0.91. What is the ratio of the Rating (1=low 6=high) of 2008 in Heavily indebted poor countries to that in Latin America(all income levels)?
Your answer should be compact. 0.92. What is the ratio of the Rating (1=low 6=high) in 2005 in Heavily indebted poor countries to that in Latin America(developing only)?
Give a very brief answer. 0.9. What is the ratio of the Rating (1=low 6=high) in 2006 in Heavily indebted poor countries to that in Latin America(developing only)?
Provide a short and direct response. 0.88. What is the ratio of the Rating (1=low 6=high) in 2007 in Heavily indebted poor countries to that in Latin America(developing only)?
Give a very brief answer. 0.91. What is the ratio of the Rating (1=low 6=high) in 2008 in Heavily indebted poor countries to that in Latin America(developing only)?
Make the answer very short. 0.92. What is the ratio of the Rating (1=low 6=high) in 2006 in Latin America(all income levels) to that in Latin America(developing only)?
Your answer should be very brief. 1. What is the difference between the highest and the second highest Rating (1=low 6=high) of 2006?
Ensure brevity in your answer.  0. What is the difference between the highest and the second highest Rating (1=low 6=high) of 2008?
Your response must be concise. 0. What is the difference between the highest and the lowest Rating (1=low 6=high) in 2005?
Ensure brevity in your answer.  1.14. What is the difference between the highest and the lowest Rating (1=low 6=high) of 2006?
Make the answer very short. 1.28. What is the difference between the highest and the lowest Rating (1=low 6=high) of 2007?
Make the answer very short. 1.38. What is the difference between the highest and the lowest Rating (1=low 6=high) of 2008?
Give a very brief answer. 1.32. 